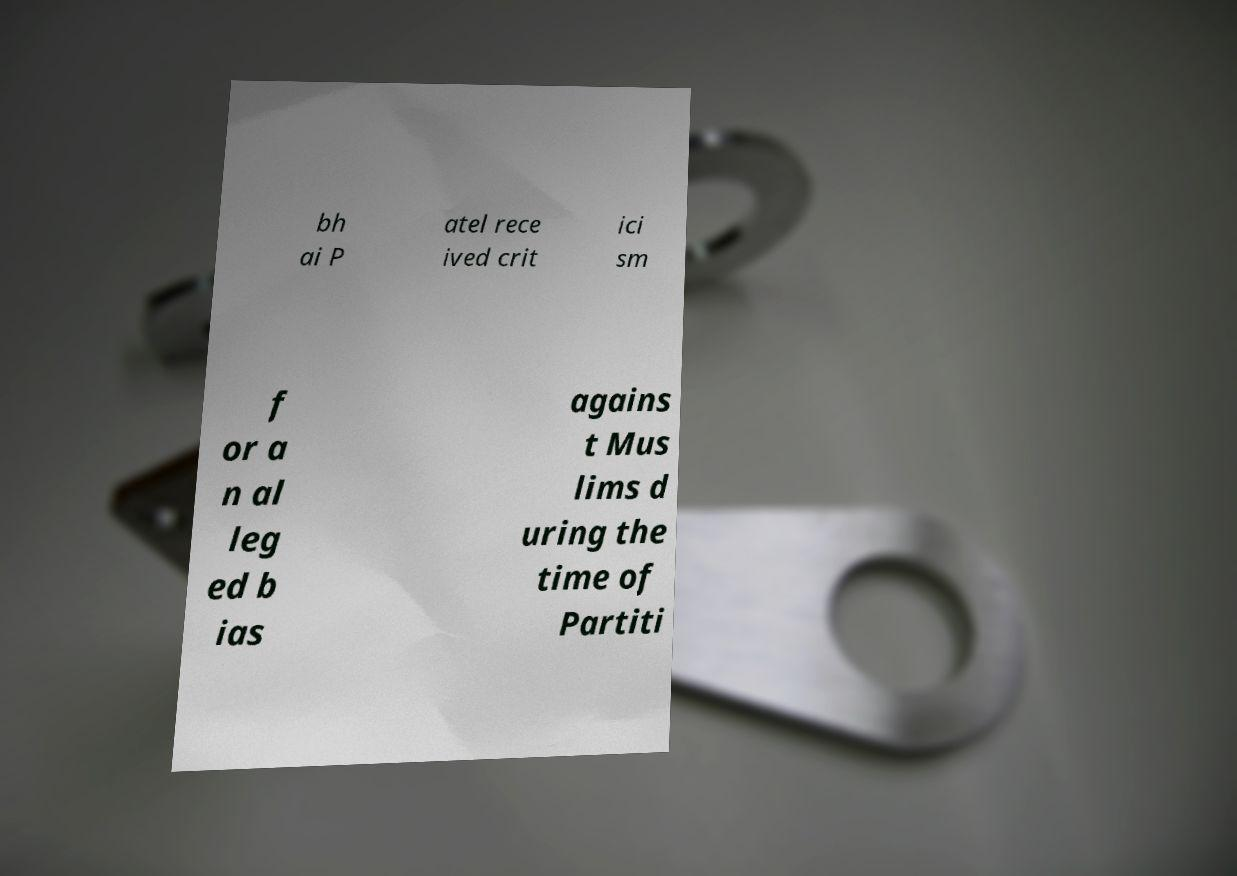Please identify and transcribe the text found in this image. bh ai P atel rece ived crit ici sm f or a n al leg ed b ias agains t Mus lims d uring the time of Partiti 